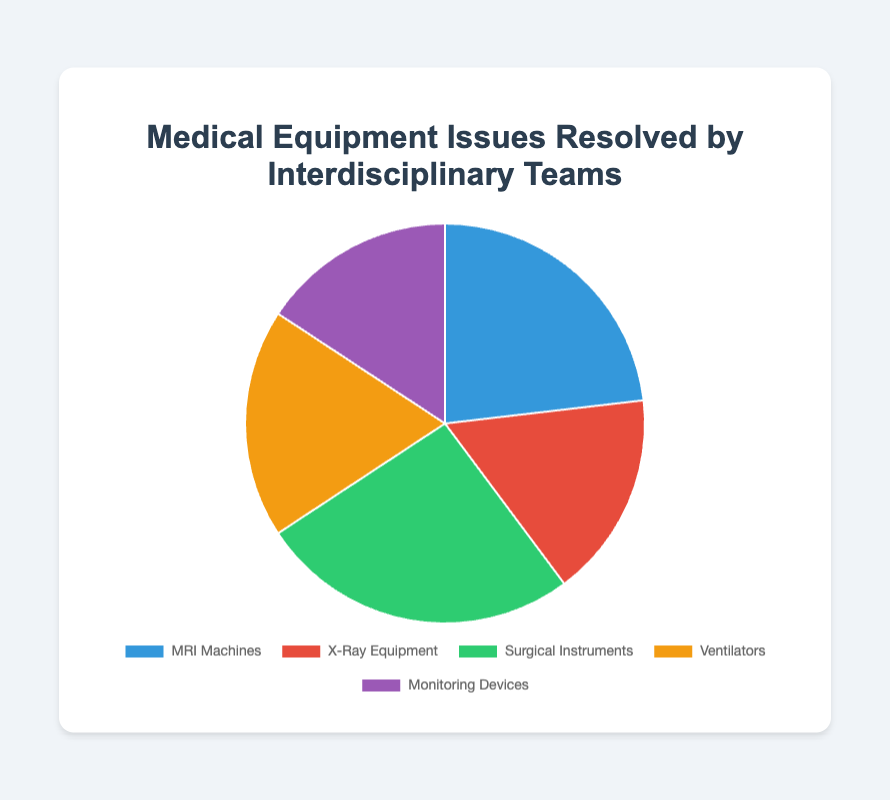What is the total number of issues resolved for all equipment types? To find the total number of issues resolved, sum the values for all equipment types. Add 125 (MRI Machines) + 90 (X-Ray Equipment) + 140 (Surgical Instruments) + 100 (Ventilators) + 85 (Monitoring Devices) = 540.
Answer: 540 Which equipment type had the highest number of issues resolved? The equipment type with the highest number of issues resolved can be identified by comparing the numbers. The values are 125 (MRI Machines), 90 (X-Ray Equipment), 140 (Surgical Instruments), 100 (Ventilators), and 85 (Monitoring Devices). The highest value is 140 for Surgical Instruments.
Answer: Surgical Instruments How does the number of issues resolved for MRI Machines compare to X-Ray Equipment? To compare, subtract the number of issues resolved for X-Ray Equipment from MRI Machines: 125 (MRI Machines) - 90 (X-Ray Equipment) = 35. MRI Machines had 35 more issues resolved.
Answer: 35 more What is the average number of issues resolved per equipment type? To find the average, sum the total number of issues resolved (540) and divide by the number of equipment types (5). 540 ÷ 5 = 108.
Answer: 108 What is the difference in issues resolved between the highest and lowest equipment types? The highest number of issues resolved is for Surgical Instruments (140), and the lowest is for Monitoring Devices (85). Subtract to find the difference: 140 - 85 = 55.
Answer: 55 Which color represents Ventilators in the pie chart? Each equipment type is represented by a different color. For Ventilators, the color is yellow.
Answer: Yellow What percentage of the total issues resolved does Monitoring Devices represent? To find the percentage, divide the number of issues resolved for Monitoring Devices by the total and multiply by 100: (85 / 540) x 100 ≈ 15.74%.
Answer: 15.74% Between MRI Machines and Ventilators, which equipment type had fewer issues resolved, and by how much? MRI Machines had 125 issues resolved, and Ventilators had 100. To find the difference, subtract: 125 - 100 = 25. Ventilators had 25 fewer issues resolved.
Answer: Ventilators, 25 fewer If we combine the issues resolved for X-Ray Equipment and Monitoring Devices, what percentage of the total issues resolved does this new combination represent? First, sum the issues resolved for X-Ray Equipment (90) and Monitoring Devices (85): 90 + 85 = 175. Next, calculate the percentage: (175 / 540) x 100 ≈ 32.41%.
Answer: 32.41% 